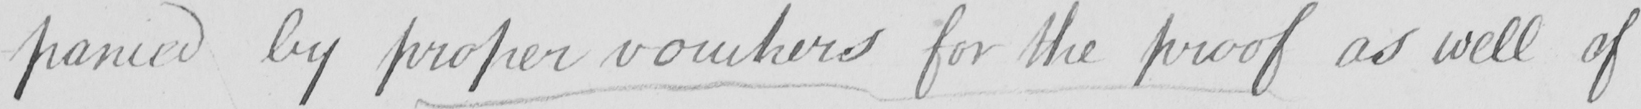Transcribe the text shown in this historical manuscript line. -panied by proper vouchers for the proof as well of 